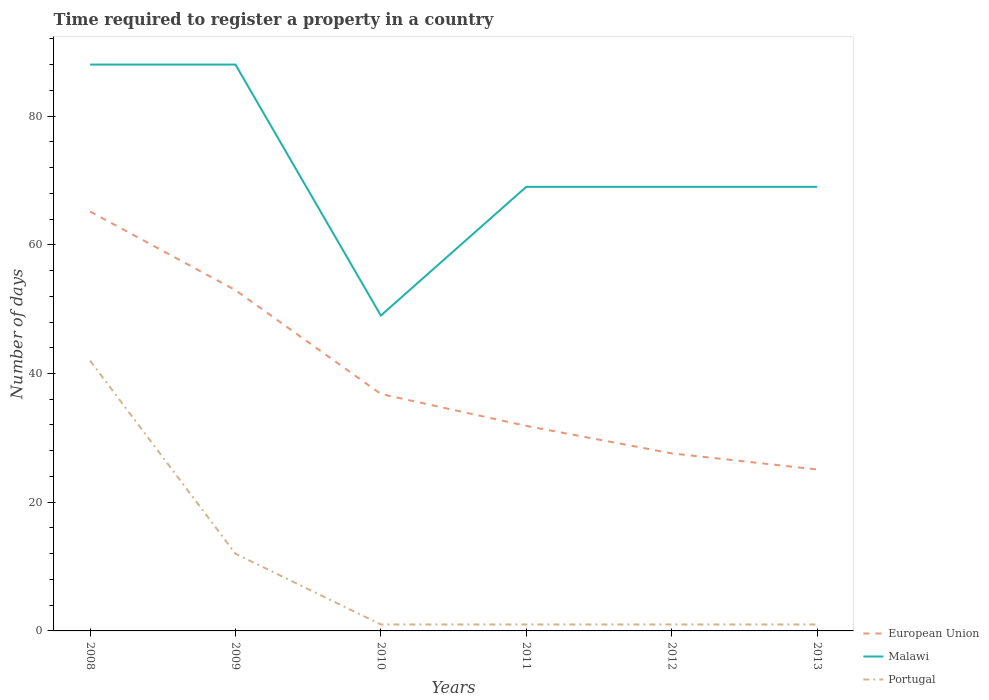Does the line corresponding to European Union intersect with the line corresponding to Malawi?
Give a very brief answer. No. Is the number of lines equal to the number of legend labels?
Provide a succinct answer. Yes. Across all years, what is the maximum number of days required to register a property in Portugal?
Keep it short and to the point. 1. What is the total number of days required to register a property in Malawi in the graph?
Your answer should be very brief. 0. What is the difference between the highest and the second highest number of days required to register a property in Portugal?
Your answer should be very brief. 41. What is the difference between the highest and the lowest number of days required to register a property in Malawi?
Offer a terse response. 2. How many years are there in the graph?
Provide a succinct answer. 6. How many legend labels are there?
Offer a very short reply. 3. What is the title of the graph?
Your answer should be compact. Time required to register a property in a country. What is the label or title of the X-axis?
Your answer should be compact. Years. What is the label or title of the Y-axis?
Provide a short and direct response. Number of days. What is the Number of days of European Union in 2008?
Provide a succinct answer. 65.17. What is the Number of days in Malawi in 2008?
Provide a succinct answer. 88. What is the Number of days in Portugal in 2008?
Make the answer very short. 42. What is the Number of days in European Union in 2009?
Give a very brief answer. 52.94. What is the Number of days in European Union in 2010?
Give a very brief answer. 36.81. What is the Number of days of European Union in 2011?
Offer a terse response. 31.86. What is the Number of days in European Union in 2012?
Provide a succinct answer. 27.59. What is the Number of days of Malawi in 2012?
Offer a terse response. 69. What is the Number of days of European Union in 2013?
Your answer should be compact. 25.09. What is the Number of days in Malawi in 2013?
Your response must be concise. 69. What is the Number of days of Portugal in 2013?
Offer a very short reply. 1. Across all years, what is the maximum Number of days of European Union?
Provide a short and direct response. 65.17. Across all years, what is the maximum Number of days in Portugal?
Offer a very short reply. 42. Across all years, what is the minimum Number of days of European Union?
Give a very brief answer. 25.09. What is the total Number of days in European Union in the graph?
Give a very brief answer. 239.46. What is the total Number of days of Malawi in the graph?
Ensure brevity in your answer.  432. What is the total Number of days in Portugal in the graph?
Make the answer very short. 58. What is the difference between the Number of days of European Union in 2008 and that in 2009?
Make the answer very short. 12.22. What is the difference between the Number of days in Malawi in 2008 and that in 2009?
Provide a succinct answer. 0. What is the difference between the Number of days of Portugal in 2008 and that in 2009?
Offer a terse response. 30. What is the difference between the Number of days in European Union in 2008 and that in 2010?
Offer a very short reply. 28.35. What is the difference between the Number of days in European Union in 2008 and that in 2011?
Make the answer very short. 33.31. What is the difference between the Number of days of Malawi in 2008 and that in 2011?
Ensure brevity in your answer.  19. What is the difference between the Number of days of European Union in 2008 and that in 2012?
Offer a terse response. 37.58. What is the difference between the Number of days of Malawi in 2008 and that in 2012?
Your response must be concise. 19. What is the difference between the Number of days in European Union in 2008 and that in 2013?
Ensure brevity in your answer.  40.08. What is the difference between the Number of days in Malawi in 2008 and that in 2013?
Offer a terse response. 19. What is the difference between the Number of days in European Union in 2009 and that in 2010?
Your answer should be very brief. 16.13. What is the difference between the Number of days of Malawi in 2009 and that in 2010?
Keep it short and to the point. 39. What is the difference between the Number of days of Portugal in 2009 and that in 2010?
Keep it short and to the point. 11. What is the difference between the Number of days of European Union in 2009 and that in 2011?
Offer a terse response. 21.09. What is the difference between the Number of days of European Union in 2009 and that in 2012?
Your answer should be compact. 25.36. What is the difference between the Number of days of Malawi in 2009 and that in 2012?
Your response must be concise. 19. What is the difference between the Number of days of Portugal in 2009 and that in 2012?
Your answer should be compact. 11. What is the difference between the Number of days in European Union in 2009 and that in 2013?
Keep it short and to the point. 27.86. What is the difference between the Number of days of European Union in 2010 and that in 2011?
Your response must be concise. 4.96. What is the difference between the Number of days of European Union in 2010 and that in 2012?
Offer a very short reply. 9.23. What is the difference between the Number of days of Malawi in 2010 and that in 2012?
Offer a terse response. -20. What is the difference between the Number of days of European Union in 2010 and that in 2013?
Keep it short and to the point. 11.73. What is the difference between the Number of days in European Union in 2011 and that in 2012?
Ensure brevity in your answer.  4.27. What is the difference between the Number of days of European Union in 2011 and that in 2013?
Make the answer very short. 6.77. What is the difference between the Number of days of Portugal in 2011 and that in 2013?
Your answer should be compact. 0. What is the difference between the Number of days of European Union in 2012 and that in 2013?
Your answer should be very brief. 2.5. What is the difference between the Number of days of Portugal in 2012 and that in 2013?
Your response must be concise. 0. What is the difference between the Number of days in European Union in 2008 and the Number of days in Malawi in 2009?
Provide a short and direct response. -22.83. What is the difference between the Number of days of European Union in 2008 and the Number of days of Portugal in 2009?
Your response must be concise. 53.17. What is the difference between the Number of days in Malawi in 2008 and the Number of days in Portugal in 2009?
Your response must be concise. 76. What is the difference between the Number of days in European Union in 2008 and the Number of days in Malawi in 2010?
Offer a terse response. 16.17. What is the difference between the Number of days of European Union in 2008 and the Number of days of Portugal in 2010?
Provide a short and direct response. 64.17. What is the difference between the Number of days of Malawi in 2008 and the Number of days of Portugal in 2010?
Your answer should be compact. 87. What is the difference between the Number of days in European Union in 2008 and the Number of days in Malawi in 2011?
Make the answer very short. -3.83. What is the difference between the Number of days of European Union in 2008 and the Number of days of Portugal in 2011?
Provide a short and direct response. 64.17. What is the difference between the Number of days in Malawi in 2008 and the Number of days in Portugal in 2011?
Your response must be concise. 87. What is the difference between the Number of days in European Union in 2008 and the Number of days in Malawi in 2012?
Give a very brief answer. -3.83. What is the difference between the Number of days in European Union in 2008 and the Number of days in Portugal in 2012?
Provide a succinct answer. 64.17. What is the difference between the Number of days of European Union in 2008 and the Number of days of Malawi in 2013?
Your answer should be very brief. -3.83. What is the difference between the Number of days of European Union in 2008 and the Number of days of Portugal in 2013?
Provide a succinct answer. 64.17. What is the difference between the Number of days in Malawi in 2008 and the Number of days in Portugal in 2013?
Provide a succinct answer. 87. What is the difference between the Number of days in European Union in 2009 and the Number of days in Malawi in 2010?
Offer a very short reply. 3.94. What is the difference between the Number of days in European Union in 2009 and the Number of days in Portugal in 2010?
Your response must be concise. 51.94. What is the difference between the Number of days of Malawi in 2009 and the Number of days of Portugal in 2010?
Your response must be concise. 87. What is the difference between the Number of days in European Union in 2009 and the Number of days in Malawi in 2011?
Keep it short and to the point. -16.06. What is the difference between the Number of days of European Union in 2009 and the Number of days of Portugal in 2011?
Make the answer very short. 51.94. What is the difference between the Number of days in Malawi in 2009 and the Number of days in Portugal in 2011?
Your response must be concise. 87. What is the difference between the Number of days in European Union in 2009 and the Number of days in Malawi in 2012?
Provide a short and direct response. -16.06. What is the difference between the Number of days of European Union in 2009 and the Number of days of Portugal in 2012?
Keep it short and to the point. 51.94. What is the difference between the Number of days of Malawi in 2009 and the Number of days of Portugal in 2012?
Provide a succinct answer. 87. What is the difference between the Number of days in European Union in 2009 and the Number of days in Malawi in 2013?
Make the answer very short. -16.06. What is the difference between the Number of days of European Union in 2009 and the Number of days of Portugal in 2013?
Your answer should be compact. 51.94. What is the difference between the Number of days in Malawi in 2009 and the Number of days in Portugal in 2013?
Offer a very short reply. 87. What is the difference between the Number of days of European Union in 2010 and the Number of days of Malawi in 2011?
Your answer should be compact. -32.19. What is the difference between the Number of days of European Union in 2010 and the Number of days of Portugal in 2011?
Your answer should be compact. 35.81. What is the difference between the Number of days in European Union in 2010 and the Number of days in Malawi in 2012?
Keep it short and to the point. -32.19. What is the difference between the Number of days in European Union in 2010 and the Number of days in Portugal in 2012?
Your answer should be very brief. 35.81. What is the difference between the Number of days of Malawi in 2010 and the Number of days of Portugal in 2012?
Your response must be concise. 48. What is the difference between the Number of days in European Union in 2010 and the Number of days in Malawi in 2013?
Your answer should be very brief. -32.19. What is the difference between the Number of days in European Union in 2010 and the Number of days in Portugal in 2013?
Offer a very short reply. 35.81. What is the difference between the Number of days in Malawi in 2010 and the Number of days in Portugal in 2013?
Your answer should be very brief. 48. What is the difference between the Number of days of European Union in 2011 and the Number of days of Malawi in 2012?
Ensure brevity in your answer.  -37.14. What is the difference between the Number of days in European Union in 2011 and the Number of days in Portugal in 2012?
Provide a short and direct response. 30.86. What is the difference between the Number of days of European Union in 2011 and the Number of days of Malawi in 2013?
Make the answer very short. -37.14. What is the difference between the Number of days of European Union in 2011 and the Number of days of Portugal in 2013?
Your answer should be compact. 30.86. What is the difference between the Number of days in Malawi in 2011 and the Number of days in Portugal in 2013?
Provide a succinct answer. 68. What is the difference between the Number of days in European Union in 2012 and the Number of days in Malawi in 2013?
Offer a terse response. -41.41. What is the difference between the Number of days in European Union in 2012 and the Number of days in Portugal in 2013?
Keep it short and to the point. 26.59. What is the difference between the Number of days in Malawi in 2012 and the Number of days in Portugal in 2013?
Your answer should be compact. 68. What is the average Number of days in European Union per year?
Ensure brevity in your answer.  39.91. What is the average Number of days in Malawi per year?
Keep it short and to the point. 72. What is the average Number of days of Portugal per year?
Your answer should be very brief. 9.67. In the year 2008, what is the difference between the Number of days of European Union and Number of days of Malawi?
Keep it short and to the point. -22.83. In the year 2008, what is the difference between the Number of days of European Union and Number of days of Portugal?
Provide a succinct answer. 23.17. In the year 2009, what is the difference between the Number of days of European Union and Number of days of Malawi?
Offer a terse response. -35.06. In the year 2009, what is the difference between the Number of days in European Union and Number of days in Portugal?
Provide a succinct answer. 40.94. In the year 2010, what is the difference between the Number of days of European Union and Number of days of Malawi?
Give a very brief answer. -12.19. In the year 2010, what is the difference between the Number of days in European Union and Number of days in Portugal?
Your answer should be very brief. 35.81. In the year 2011, what is the difference between the Number of days in European Union and Number of days in Malawi?
Your answer should be very brief. -37.14. In the year 2011, what is the difference between the Number of days of European Union and Number of days of Portugal?
Give a very brief answer. 30.86. In the year 2012, what is the difference between the Number of days of European Union and Number of days of Malawi?
Offer a terse response. -41.41. In the year 2012, what is the difference between the Number of days in European Union and Number of days in Portugal?
Offer a very short reply. 26.59. In the year 2013, what is the difference between the Number of days of European Union and Number of days of Malawi?
Provide a short and direct response. -43.91. In the year 2013, what is the difference between the Number of days of European Union and Number of days of Portugal?
Your answer should be compact. 24.09. What is the ratio of the Number of days of European Union in 2008 to that in 2009?
Give a very brief answer. 1.23. What is the ratio of the Number of days in Malawi in 2008 to that in 2009?
Give a very brief answer. 1. What is the ratio of the Number of days in Portugal in 2008 to that in 2009?
Offer a terse response. 3.5. What is the ratio of the Number of days of European Union in 2008 to that in 2010?
Your answer should be compact. 1.77. What is the ratio of the Number of days in Malawi in 2008 to that in 2010?
Give a very brief answer. 1.8. What is the ratio of the Number of days in Portugal in 2008 to that in 2010?
Your response must be concise. 42. What is the ratio of the Number of days in European Union in 2008 to that in 2011?
Your answer should be compact. 2.05. What is the ratio of the Number of days of Malawi in 2008 to that in 2011?
Provide a succinct answer. 1.28. What is the ratio of the Number of days of Portugal in 2008 to that in 2011?
Your answer should be very brief. 42. What is the ratio of the Number of days in European Union in 2008 to that in 2012?
Ensure brevity in your answer.  2.36. What is the ratio of the Number of days of Malawi in 2008 to that in 2012?
Make the answer very short. 1.28. What is the ratio of the Number of days of European Union in 2008 to that in 2013?
Your answer should be very brief. 2.6. What is the ratio of the Number of days in Malawi in 2008 to that in 2013?
Give a very brief answer. 1.28. What is the ratio of the Number of days in European Union in 2009 to that in 2010?
Ensure brevity in your answer.  1.44. What is the ratio of the Number of days in Malawi in 2009 to that in 2010?
Your answer should be compact. 1.8. What is the ratio of the Number of days in Portugal in 2009 to that in 2010?
Offer a very short reply. 12. What is the ratio of the Number of days in European Union in 2009 to that in 2011?
Provide a succinct answer. 1.66. What is the ratio of the Number of days in Malawi in 2009 to that in 2011?
Provide a short and direct response. 1.28. What is the ratio of the Number of days of Portugal in 2009 to that in 2011?
Your response must be concise. 12. What is the ratio of the Number of days in European Union in 2009 to that in 2012?
Give a very brief answer. 1.92. What is the ratio of the Number of days in Malawi in 2009 to that in 2012?
Your response must be concise. 1.28. What is the ratio of the Number of days of European Union in 2009 to that in 2013?
Your answer should be very brief. 2.11. What is the ratio of the Number of days of Malawi in 2009 to that in 2013?
Provide a succinct answer. 1.28. What is the ratio of the Number of days of Portugal in 2009 to that in 2013?
Your answer should be compact. 12. What is the ratio of the Number of days of European Union in 2010 to that in 2011?
Provide a short and direct response. 1.16. What is the ratio of the Number of days of Malawi in 2010 to that in 2011?
Make the answer very short. 0.71. What is the ratio of the Number of days in Portugal in 2010 to that in 2011?
Provide a succinct answer. 1. What is the ratio of the Number of days in European Union in 2010 to that in 2012?
Keep it short and to the point. 1.33. What is the ratio of the Number of days of Malawi in 2010 to that in 2012?
Offer a terse response. 0.71. What is the ratio of the Number of days in European Union in 2010 to that in 2013?
Provide a short and direct response. 1.47. What is the ratio of the Number of days in Malawi in 2010 to that in 2013?
Offer a very short reply. 0.71. What is the ratio of the Number of days of European Union in 2011 to that in 2012?
Offer a very short reply. 1.15. What is the ratio of the Number of days of Malawi in 2011 to that in 2012?
Offer a very short reply. 1. What is the ratio of the Number of days of European Union in 2011 to that in 2013?
Keep it short and to the point. 1.27. What is the ratio of the Number of days in Malawi in 2011 to that in 2013?
Offer a terse response. 1. What is the ratio of the Number of days of Portugal in 2011 to that in 2013?
Your answer should be very brief. 1. What is the ratio of the Number of days of European Union in 2012 to that in 2013?
Make the answer very short. 1.1. What is the ratio of the Number of days in Malawi in 2012 to that in 2013?
Offer a terse response. 1. What is the ratio of the Number of days of Portugal in 2012 to that in 2013?
Your answer should be compact. 1. What is the difference between the highest and the second highest Number of days in European Union?
Your answer should be very brief. 12.22. What is the difference between the highest and the second highest Number of days in Malawi?
Give a very brief answer. 0. What is the difference between the highest and the second highest Number of days of Portugal?
Make the answer very short. 30. What is the difference between the highest and the lowest Number of days of European Union?
Give a very brief answer. 40.08. What is the difference between the highest and the lowest Number of days in Malawi?
Offer a very short reply. 39. 